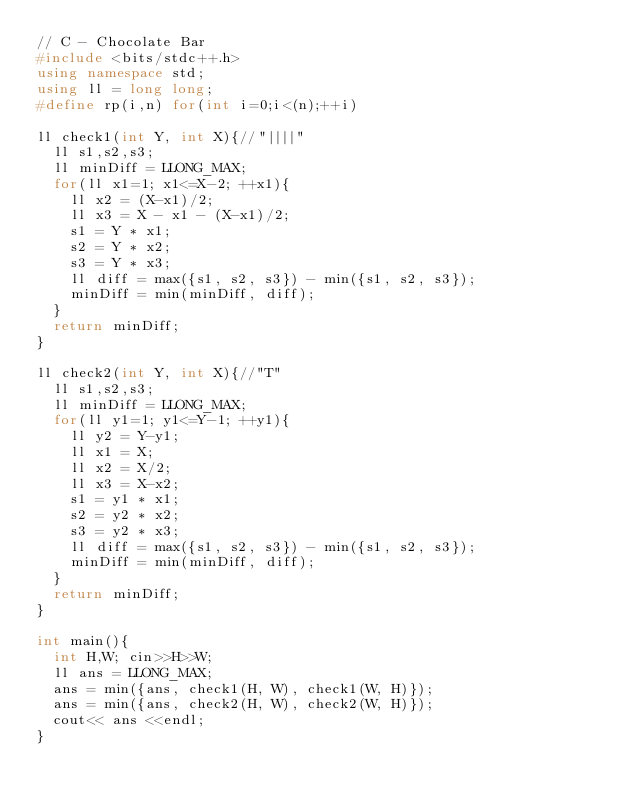Convert code to text. <code><loc_0><loc_0><loc_500><loc_500><_C++_>// C - Chocolate Bar
#include <bits/stdc++.h>
using namespace std;
using ll = long long;
#define rp(i,n) for(int i=0;i<(n);++i)

ll check1(int Y, int X){//"||||"
	ll s1,s2,s3;
	ll minDiff = LLONG_MAX;
	for(ll x1=1; x1<=X-2; ++x1){
		ll x2 = (X-x1)/2;
		ll x3 = X - x1 - (X-x1)/2;
		s1 = Y * x1;
		s2 = Y * x2;
		s3 = Y * x3;
		ll diff = max({s1, s2, s3}) - min({s1, s2, s3});
		minDiff = min(minDiff, diff);
	}
	return minDiff;
}

ll check2(int Y, int X){//"T"
	ll s1,s2,s3;
	ll minDiff = LLONG_MAX;
	for(ll y1=1; y1<=Y-1; ++y1){
		ll y2 = Y-y1;
		ll x1 = X;
		ll x2 = X/2;
		ll x3 = X-x2;
		s1 = y1 * x1;
		s2 = y2 * x2;
		s3 = y2 * x3;
		ll diff = max({s1, s2, s3}) - min({s1, s2, s3});
		minDiff = min(minDiff, diff);
	}
	return minDiff;
}

int main(){
	int H,W; cin>>H>>W;
	ll ans = LLONG_MAX;
	ans = min({ans, check1(H, W), check1(W, H)});
	ans = min({ans, check2(H, W), check2(W, H)});
	cout<< ans <<endl;
}</code> 